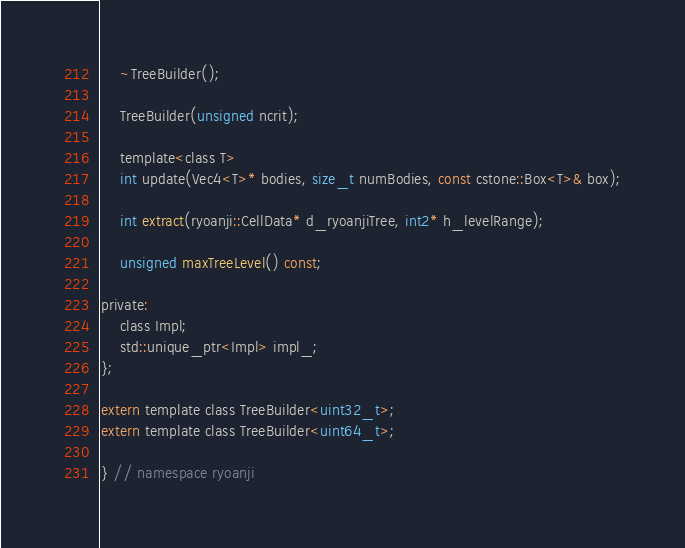Convert code to text. <code><loc_0><loc_0><loc_500><loc_500><_Cuda_>    ~TreeBuilder();

    TreeBuilder(unsigned ncrit);

    template<class T>
    int update(Vec4<T>* bodies, size_t numBodies, const cstone::Box<T>& box);

    int extract(ryoanji::CellData* d_ryoanjiTree, int2* h_levelRange);

    unsigned maxTreeLevel() const;

private:
    class Impl;
    std::unique_ptr<Impl> impl_;
};

extern template class TreeBuilder<uint32_t>;
extern template class TreeBuilder<uint64_t>;

} // namespace ryoanji
</code> 